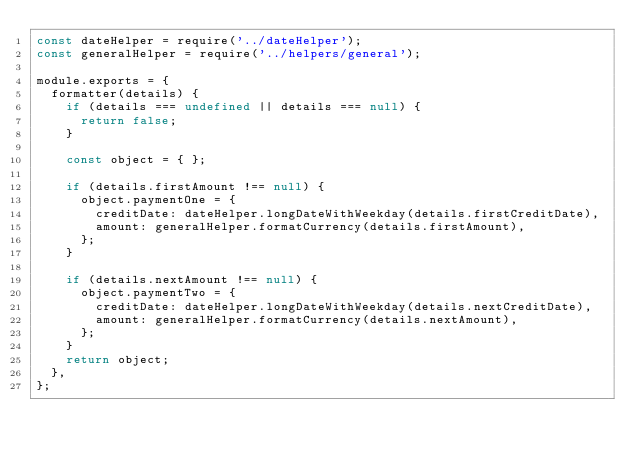<code> <loc_0><loc_0><loc_500><loc_500><_JavaScript_>const dateHelper = require('../dateHelper');
const generalHelper = require('../helpers/general');

module.exports = {
  formatter(details) {
    if (details === undefined || details === null) {
      return false;
    }

    const object = { };

    if (details.firstAmount !== null) {
      object.paymentOne = {
        creditDate: dateHelper.longDateWithWeekday(details.firstCreditDate),
        amount: generalHelper.formatCurrency(details.firstAmount),
      };
    }

    if (details.nextAmount !== null) {
      object.paymentTwo = {
        creditDate: dateHelper.longDateWithWeekday(details.nextCreditDate),
        amount: generalHelper.formatCurrency(details.nextAmount),
      };
    }
    return object;
  },
};
</code> 